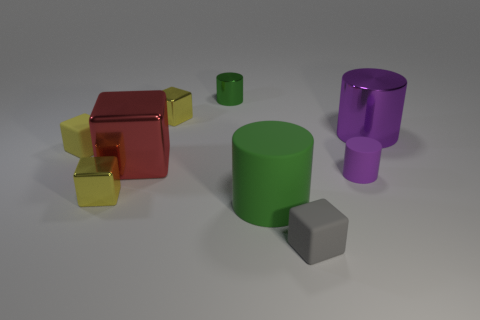What do the varying sizes of these objects suggest about perspective and depth in the image? The varying sizes of the objects, combined with their arrangement, create a sense of depth in the image. Smaller objects appear farther away due to the principles of perspective, where parallel lines seem to converge in the distance. This can be seen with the smaller yellow cubes in relation to the larger red cube. Furthermore, the scale difference between the green cylinders of different sizes also contributes to creating a three-dimensional effect on a two-dimensional medium. 